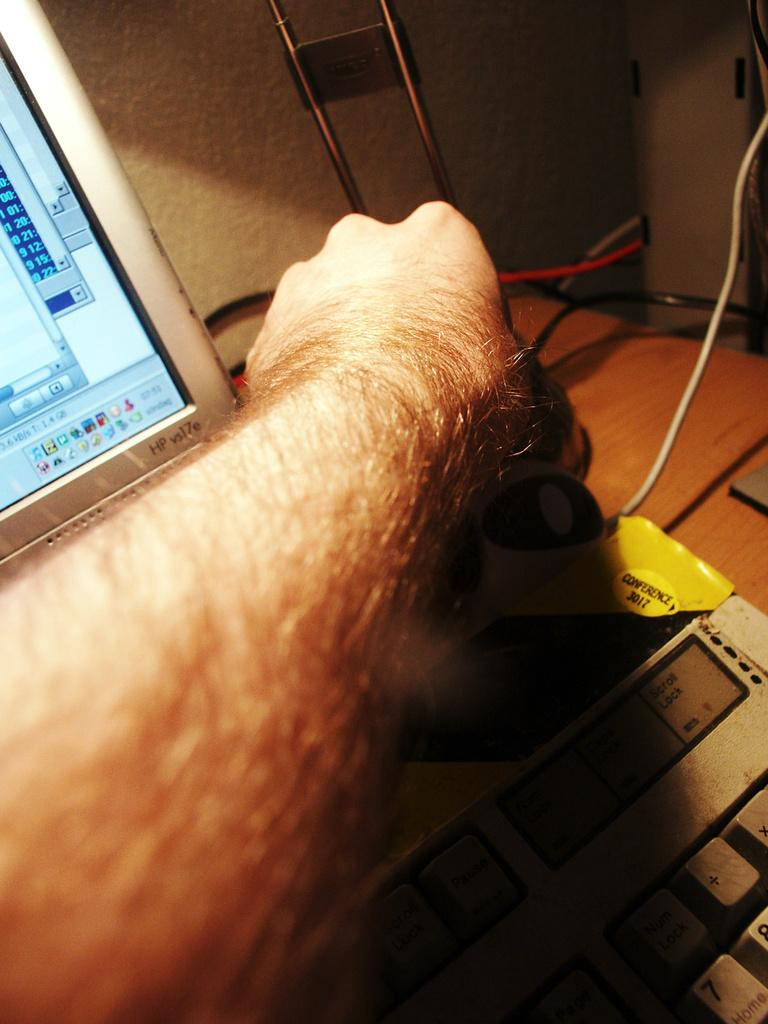<image>
Provide a brief description of the given image. A man's arm is reaching past an HP vs17e monitor. 